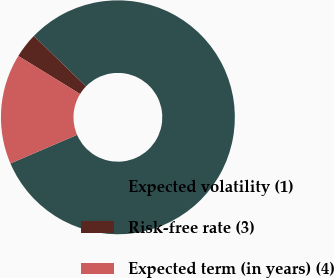Convert chart to OTSL. <chart><loc_0><loc_0><loc_500><loc_500><pie_chart><fcel>Expected volatility (1)<fcel>Risk-free rate (3)<fcel>Expected term (in years) (4)<nl><fcel>81.3%<fcel>3.46%<fcel>15.24%<nl></chart> 